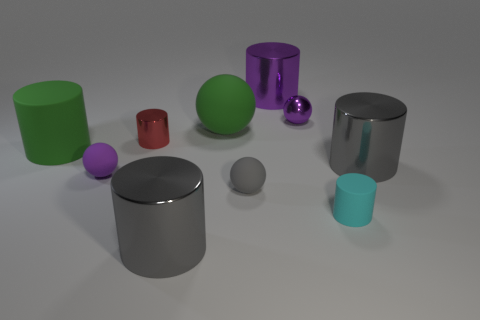There is a purple matte thing; is it the same size as the gray shiny object that is on the left side of the tiny cyan cylinder?
Provide a succinct answer. No. Are there fewer gray rubber objects than large gray shiny cylinders?
Offer a terse response. Yes. There is a ball that is right of the small red cylinder and in front of the tiny red metal thing; what material is it?
Offer a terse response. Rubber. There is a purple ball that is to the left of the purple sphere that is behind the large gray object behind the gray sphere; how big is it?
Ensure brevity in your answer.  Small. Do the small red thing and the large gray shiny thing that is behind the cyan matte object have the same shape?
Offer a terse response. Yes. What number of cylinders are behind the cyan rubber thing and on the right side of the gray rubber ball?
Provide a succinct answer. 2. What number of cyan things are big matte cylinders or matte objects?
Your answer should be compact. 1. There is a small cylinder that is to the left of the small cyan cylinder; does it have the same color as the matte cylinder that is on the left side of the large purple shiny object?
Provide a short and direct response. No. There is a shiny cylinder left of the metallic thing that is in front of the purple sphere left of the tiny gray rubber thing; what is its color?
Offer a terse response. Red. There is a ball that is in front of the small purple matte ball; are there any shiny balls in front of it?
Keep it short and to the point. No. 